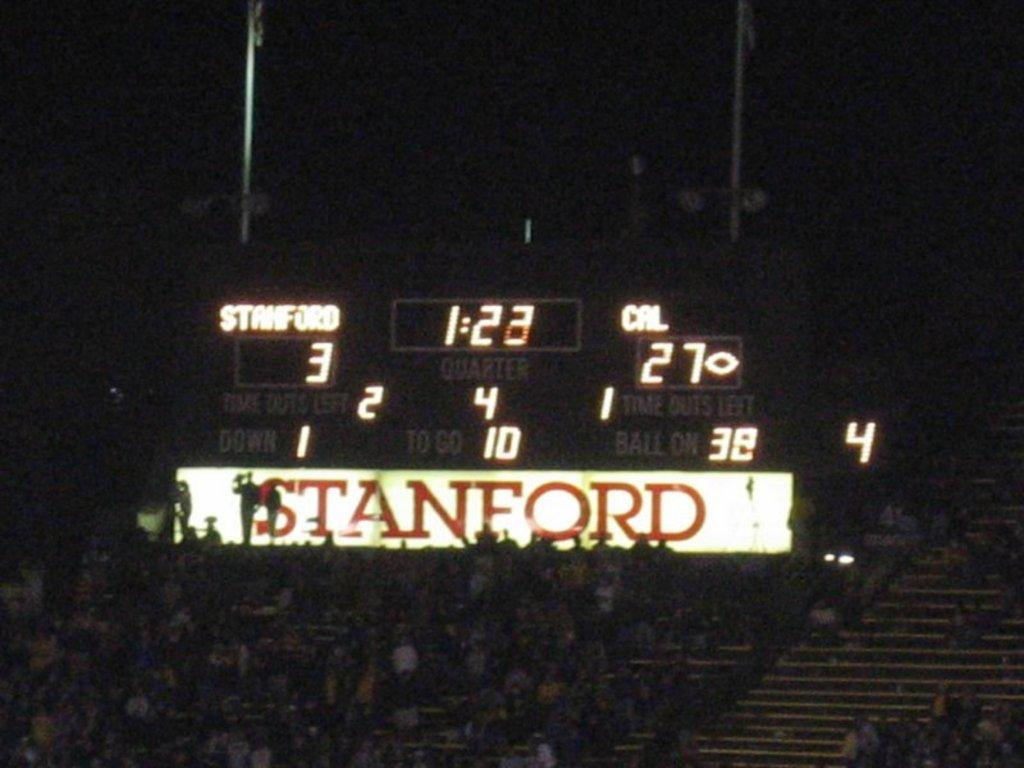<image>
Give a short and clear explanation of the subsequent image. A scoreboard showing that Stanford is losing 3 to 27 